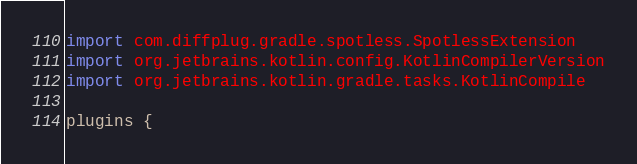Convert code to text. <code><loc_0><loc_0><loc_500><loc_500><_Kotlin_>import com.diffplug.gradle.spotless.SpotlessExtension
import org.jetbrains.kotlin.config.KotlinCompilerVersion
import org.jetbrains.kotlin.gradle.tasks.KotlinCompile

plugins {</code> 